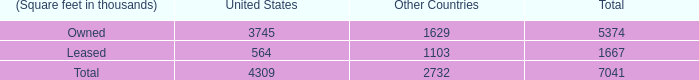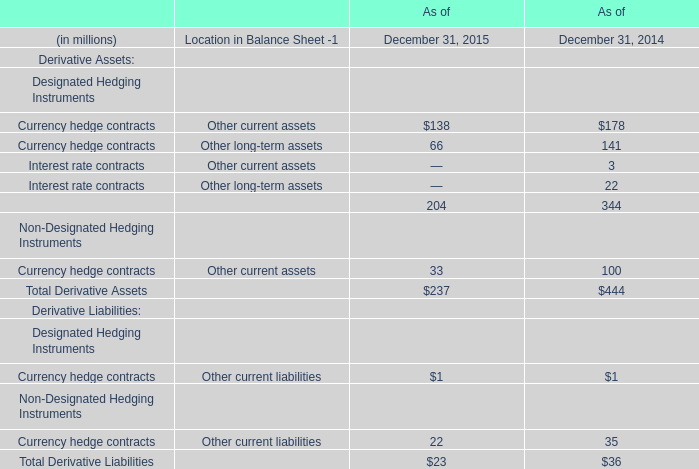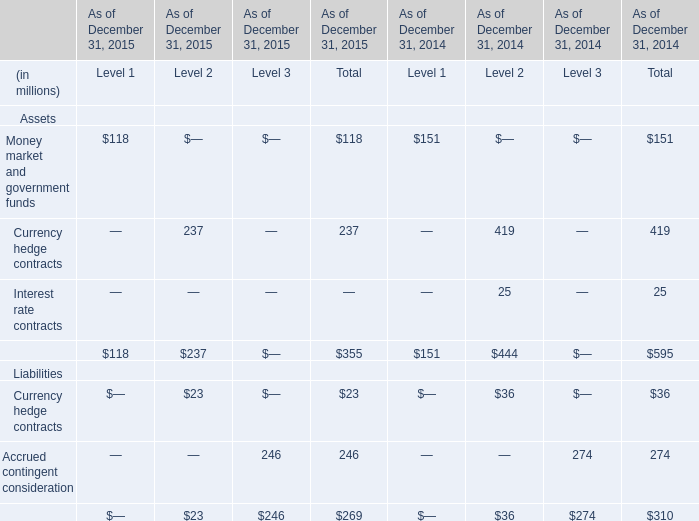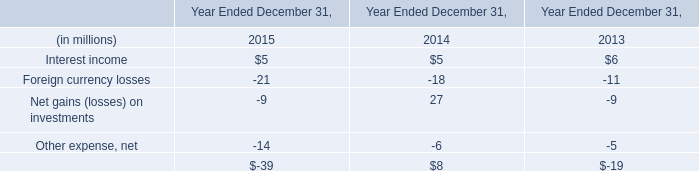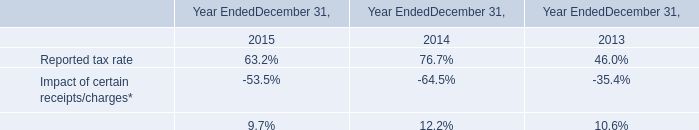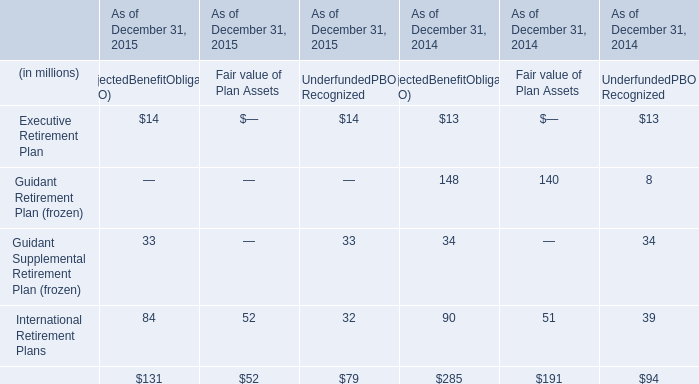If Currency hedge contracts of Other current assets develops with the same growth rate in 2015, what will it reach in 2016? (in million) 
Computations: (138 + ((138 * (138 - 178)) / 178))
Answer: 106.98876. 